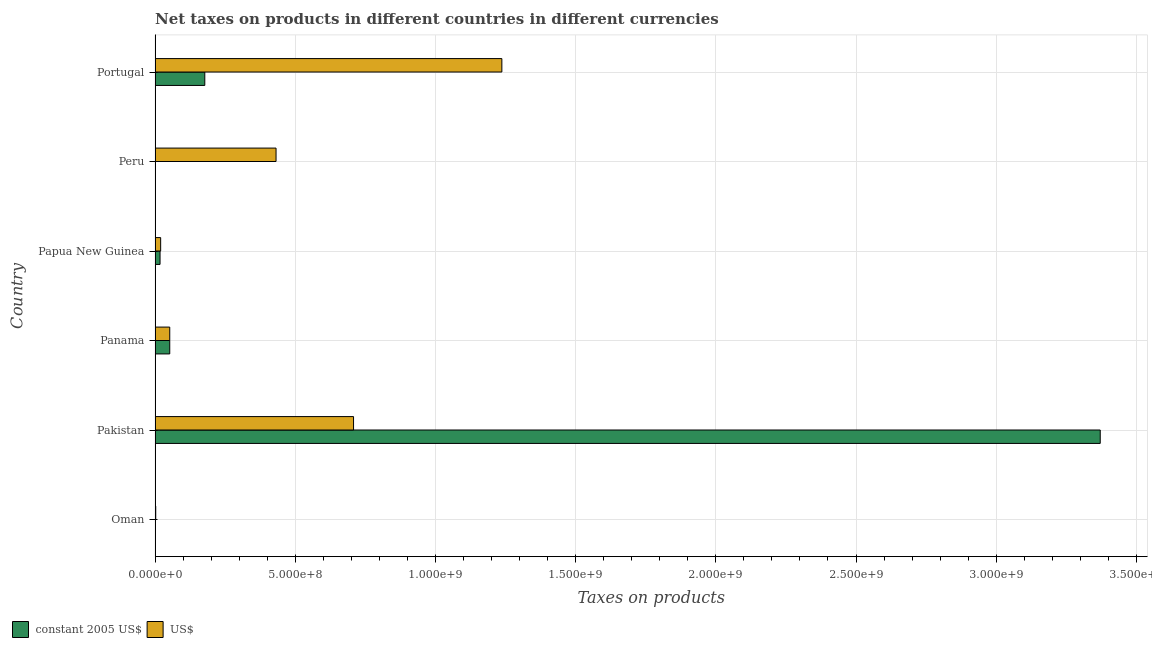How many bars are there on the 5th tick from the top?
Your answer should be compact. 2. In how many cases, is the number of bars for a given country not equal to the number of legend labels?
Your answer should be very brief. 0. What is the net taxes in us$ in Oman?
Keep it short and to the point. 2.40e+06. Across all countries, what is the maximum net taxes in us$?
Give a very brief answer. 1.24e+09. Across all countries, what is the minimum net taxes in constant 2005 us$?
Your response must be concise. 16.7. In which country was the net taxes in constant 2005 us$ maximum?
Provide a succinct answer. Pakistan. In which country was the net taxes in constant 2005 us$ minimum?
Provide a short and direct response. Peru. What is the total net taxes in constant 2005 us$ in the graph?
Your response must be concise. 3.62e+09. What is the difference between the net taxes in constant 2005 us$ in Oman and that in Papua New Guinea?
Offer a very short reply. -1.68e+07. What is the difference between the net taxes in us$ in Papua New Guinea and the net taxes in constant 2005 us$ in Oman?
Your answer should be compact. 1.89e+07. What is the average net taxes in constant 2005 us$ per country?
Provide a succinct answer. 6.03e+08. What is the difference between the net taxes in constant 2005 us$ and net taxes in us$ in Pakistan?
Offer a terse response. 2.66e+09. What is the ratio of the net taxes in constant 2005 us$ in Panama to that in Peru?
Your answer should be compact. 3.14e+06. Is the difference between the net taxes in us$ in Oman and Panama greater than the difference between the net taxes in constant 2005 us$ in Oman and Panama?
Your response must be concise. Yes. What is the difference between the highest and the second highest net taxes in constant 2005 us$?
Ensure brevity in your answer.  3.19e+09. What is the difference between the highest and the lowest net taxes in us$?
Give a very brief answer. 1.23e+09. What does the 1st bar from the top in Panama represents?
Your answer should be very brief. US$. What does the 1st bar from the bottom in Oman represents?
Provide a succinct answer. Constant 2005 us$. How many bars are there?
Your answer should be very brief. 12. How many countries are there in the graph?
Provide a short and direct response. 6. Are the values on the major ticks of X-axis written in scientific E-notation?
Your answer should be very brief. Yes. Where does the legend appear in the graph?
Keep it short and to the point. Bottom left. How many legend labels are there?
Offer a terse response. 2. What is the title of the graph?
Offer a very short reply. Net taxes on products in different countries in different currencies. What is the label or title of the X-axis?
Your answer should be compact. Taxes on products. What is the label or title of the Y-axis?
Give a very brief answer. Country. What is the Taxes on products of US$ in Oman?
Give a very brief answer. 2.40e+06. What is the Taxes on products of constant 2005 US$ in Pakistan?
Your response must be concise. 3.37e+09. What is the Taxes on products of US$ in Pakistan?
Your answer should be compact. 7.08e+08. What is the Taxes on products of constant 2005 US$ in Panama?
Your response must be concise. 5.24e+07. What is the Taxes on products in US$ in Panama?
Keep it short and to the point. 5.24e+07. What is the Taxes on products of constant 2005 US$ in Papua New Guinea?
Your response must be concise. 1.78e+07. What is the Taxes on products in US$ in Papua New Guinea?
Your answer should be compact. 1.99e+07. What is the Taxes on products in constant 2005 US$ in Peru?
Offer a terse response. 16.7. What is the Taxes on products in US$ in Peru?
Your answer should be compact. 4.32e+08. What is the Taxes on products in constant 2005 US$ in Portugal?
Ensure brevity in your answer.  1.77e+08. What is the Taxes on products in US$ in Portugal?
Your answer should be compact. 1.24e+09. Across all countries, what is the maximum Taxes on products of constant 2005 US$?
Offer a terse response. 3.37e+09. Across all countries, what is the maximum Taxes on products in US$?
Offer a very short reply. 1.24e+09. Across all countries, what is the minimum Taxes on products of constant 2005 US$?
Provide a succinct answer. 16.7. Across all countries, what is the minimum Taxes on products in US$?
Offer a very short reply. 2.40e+06. What is the total Taxes on products of constant 2005 US$ in the graph?
Keep it short and to the point. 3.62e+09. What is the total Taxes on products of US$ in the graph?
Offer a terse response. 2.45e+09. What is the difference between the Taxes on products in constant 2005 US$ in Oman and that in Pakistan?
Keep it short and to the point. -3.37e+09. What is the difference between the Taxes on products in US$ in Oman and that in Pakistan?
Provide a short and direct response. -7.05e+08. What is the difference between the Taxes on products of constant 2005 US$ in Oman and that in Panama?
Provide a succinct answer. -5.14e+07. What is the difference between the Taxes on products of US$ in Oman and that in Panama?
Keep it short and to the point. -5.00e+07. What is the difference between the Taxes on products in constant 2005 US$ in Oman and that in Papua New Guinea?
Your answer should be very brief. -1.68e+07. What is the difference between the Taxes on products in US$ in Oman and that in Papua New Guinea?
Give a very brief answer. -1.75e+07. What is the difference between the Taxes on products of constant 2005 US$ in Oman and that in Peru?
Provide a short and direct response. 1.00e+06. What is the difference between the Taxes on products of US$ in Oman and that in Peru?
Offer a terse response. -4.29e+08. What is the difference between the Taxes on products of constant 2005 US$ in Oman and that in Portugal?
Your response must be concise. -1.76e+08. What is the difference between the Taxes on products of US$ in Oman and that in Portugal?
Make the answer very short. -1.23e+09. What is the difference between the Taxes on products in constant 2005 US$ in Pakistan and that in Panama?
Make the answer very short. 3.32e+09. What is the difference between the Taxes on products of US$ in Pakistan and that in Panama?
Give a very brief answer. 6.55e+08. What is the difference between the Taxes on products of constant 2005 US$ in Pakistan and that in Papua New Guinea?
Offer a very short reply. 3.35e+09. What is the difference between the Taxes on products of US$ in Pakistan and that in Papua New Guinea?
Your answer should be compact. 6.88e+08. What is the difference between the Taxes on products in constant 2005 US$ in Pakistan and that in Peru?
Provide a succinct answer. 3.37e+09. What is the difference between the Taxes on products of US$ in Pakistan and that in Peru?
Provide a short and direct response. 2.76e+08. What is the difference between the Taxes on products of constant 2005 US$ in Pakistan and that in Portugal?
Provide a short and direct response. 3.19e+09. What is the difference between the Taxes on products in US$ in Pakistan and that in Portugal?
Offer a very short reply. -5.29e+08. What is the difference between the Taxes on products in constant 2005 US$ in Panama and that in Papua New Guinea?
Your response must be concise. 3.46e+07. What is the difference between the Taxes on products in US$ in Panama and that in Papua New Guinea?
Offer a very short reply. 3.25e+07. What is the difference between the Taxes on products in constant 2005 US$ in Panama and that in Peru?
Keep it short and to the point. 5.24e+07. What is the difference between the Taxes on products in US$ in Panama and that in Peru?
Provide a succinct answer. -3.79e+08. What is the difference between the Taxes on products of constant 2005 US$ in Panama and that in Portugal?
Your answer should be compact. -1.25e+08. What is the difference between the Taxes on products of US$ in Panama and that in Portugal?
Your answer should be compact. -1.18e+09. What is the difference between the Taxes on products of constant 2005 US$ in Papua New Guinea and that in Peru?
Ensure brevity in your answer.  1.78e+07. What is the difference between the Taxes on products in US$ in Papua New Guinea and that in Peru?
Your answer should be very brief. -4.12e+08. What is the difference between the Taxes on products of constant 2005 US$ in Papua New Guinea and that in Portugal?
Make the answer very short. -1.60e+08. What is the difference between the Taxes on products in US$ in Papua New Guinea and that in Portugal?
Keep it short and to the point. -1.22e+09. What is the difference between the Taxes on products of constant 2005 US$ in Peru and that in Portugal?
Keep it short and to the point. -1.77e+08. What is the difference between the Taxes on products of US$ in Peru and that in Portugal?
Your answer should be very brief. -8.05e+08. What is the difference between the Taxes on products in constant 2005 US$ in Oman and the Taxes on products in US$ in Pakistan?
Offer a very short reply. -7.07e+08. What is the difference between the Taxes on products of constant 2005 US$ in Oman and the Taxes on products of US$ in Panama?
Offer a terse response. -5.14e+07. What is the difference between the Taxes on products of constant 2005 US$ in Oman and the Taxes on products of US$ in Papua New Guinea?
Your answer should be very brief. -1.89e+07. What is the difference between the Taxes on products in constant 2005 US$ in Oman and the Taxes on products in US$ in Peru?
Make the answer very short. -4.31e+08. What is the difference between the Taxes on products in constant 2005 US$ in Oman and the Taxes on products in US$ in Portugal?
Your response must be concise. -1.24e+09. What is the difference between the Taxes on products in constant 2005 US$ in Pakistan and the Taxes on products in US$ in Panama?
Provide a short and direct response. 3.32e+09. What is the difference between the Taxes on products of constant 2005 US$ in Pakistan and the Taxes on products of US$ in Papua New Guinea?
Your response must be concise. 3.35e+09. What is the difference between the Taxes on products of constant 2005 US$ in Pakistan and the Taxes on products of US$ in Peru?
Offer a terse response. 2.94e+09. What is the difference between the Taxes on products in constant 2005 US$ in Pakistan and the Taxes on products in US$ in Portugal?
Ensure brevity in your answer.  2.13e+09. What is the difference between the Taxes on products in constant 2005 US$ in Panama and the Taxes on products in US$ in Papua New Guinea?
Give a very brief answer. 3.25e+07. What is the difference between the Taxes on products of constant 2005 US$ in Panama and the Taxes on products of US$ in Peru?
Offer a very short reply. -3.79e+08. What is the difference between the Taxes on products in constant 2005 US$ in Panama and the Taxes on products in US$ in Portugal?
Your answer should be compact. -1.18e+09. What is the difference between the Taxes on products in constant 2005 US$ in Papua New Guinea and the Taxes on products in US$ in Peru?
Keep it short and to the point. -4.14e+08. What is the difference between the Taxes on products of constant 2005 US$ in Papua New Guinea and the Taxes on products of US$ in Portugal?
Offer a terse response. -1.22e+09. What is the difference between the Taxes on products in constant 2005 US$ in Peru and the Taxes on products in US$ in Portugal?
Ensure brevity in your answer.  -1.24e+09. What is the average Taxes on products in constant 2005 US$ per country?
Make the answer very short. 6.03e+08. What is the average Taxes on products in US$ per country?
Give a very brief answer. 4.09e+08. What is the difference between the Taxes on products in constant 2005 US$ and Taxes on products in US$ in Oman?
Your answer should be very brief. -1.40e+06. What is the difference between the Taxes on products of constant 2005 US$ and Taxes on products of US$ in Pakistan?
Your answer should be compact. 2.66e+09. What is the difference between the Taxes on products in constant 2005 US$ and Taxes on products in US$ in Papua New Guinea?
Give a very brief answer. -2.14e+06. What is the difference between the Taxes on products of constant 2005 US$ and Taxes on products of US$ in Peru?
Offer a very short reply. -4.32e+08. What is the difference between the Taxes on products in constant 2005 US$ and Taxes on products in US$ in Portugal?
Keep it short and to the point. -1.06e+09. What is the ratio of the Taxes on products of US$ in Oman to that in Pakistan?
Keep it short and to the point. 0. What is the ratio of the Taxes on products of constant 2005 US$ in Oman to that in Panama?
Offer a very short reply. 0.02. What is the ratio of the Taxes on products of US$ in Oman to that in Panama?
Your answer should be very brief. 0.05. What is the ratio of the Taxes on products of constant 2005 US$ in Oman to that in Papua New Guinea?
Keep it short and to the point. 0.06. What is the ratio of the Taxes on products of US$ in Oman to that in Papua New Guinea?
Your answer should be compact. 0.12. What is the ratio of the Taxes on products in constant 2005 US$ in Oman to that in Peru?
Offer a terse response. 5.99e+04. What is the ratio of the Taxes on products in US$ in Oman to that in Peru?
Offer a terse response. 0.01. What is the ratio of the Taxes on products in constant 2005 US$ in Oman to that in Portugal?
Your response must be concise. 0.01. What is the ratio of the Taxes on products of US$ in Oman to that in Portugal?
Offer a very short reply. 0. What is the ratio of the Taxes on products of constant 2005 US$ in Pakistan to that in Panama?
Your answer should be very brief. 64.33. What is the ratio of the Taxes on products of US$ in Pakistan to that in Panama?
Your answer should be compact. 13.51. What is the ratio of the Taxes on products in constant 2005 US$ in Pakistan to that in Papua New Guinea?
Ensure brevity in your answer.  189.38. What is the ratio of the Taxes on products in US$ in Pakistan to that in Papua New Guinea?
Give a very brief answer. 35.51. What is the ratio of the Taxes on products of constant 2005 US$ in Pakistan to that in Peru?
Your answer should be very brief. 2.02e+08. What is the ratio of the Taxes on products of US$ in Pakistan to that in Peru?
Provide a succinct answer. 1.64. What is the ratio of the Taxes on products of constant 2005 US$ in Pakistan to that in Portugal?
Your answer should be very brief. 19.01. What is the ratio of the Taxes on products of US$ in Pakistan to that in Portugal?
Your answer should be very brief. 0.57. What is the ratio of the Taxes on products in constant 2005 US$ in Panama to that in Papua New Guinea?
Your answer should be very brief. 2.94. What is the ratio of the Taxes on products of US$ in Panama to that in Papua New Guinea?
Your response must be concise. 2.63. What is the ratio of the Taxes on products of constant 2005 US$ in Panama to that in Peru?
Your answer should be very brief. 3.14e+06. What is the ratio of the Taxes on products of US$ in Panama to that in Peru?
Provide a short and direct response. 0.12. What is the ratio of the Taxes on products of constant 2005 US$ in Panama to that in Portugal?
Offer a terse response. 0.3. What is the ratio of the Taxes on products in US$ in Panama to that in Portugal?
Ensure brevity in your answer.  0.04. What is the ratio of the Taxes on products in constant 2005 US$ in Papua New Guinea to that in Peru?
Keep it short and to the point. 1.07e+06. What is the ratio of the Taxes on products of US$ in Papua New Guinea to that in Peru?
Give a very brief answer. 0.05. What is the ratio of the Taxes on products of constant 2005 US$ in Papua New Guinea to that in Portugal?
Your answer should be compact. 0.1. What is the ratio of the Taxes on products in US$ in Papua New Guinea to that in Portugal?
Offer a very short reply. 0.02. What is the ratio of the Taxes on products in US$ in Peru to that in Portugal?
Offer a terse response. 0.35. What is the difference between the highest and the second highest Taxes on products of constant 2005 US$?
Provide a succinct answer. 3.19e+09. What is the difference between the highest and the second highest Taxes on products of US$?
Keep it short and to the point. 5.29e+08. What is the difference between the highest and the lowest Taxes on products in constant 2005 US$?
Your response must be concise. 3.37e+09. What is the difference between the highest and the lowest Taxes on products in US$?
Your answer should be very brief. 1.23e+09. 